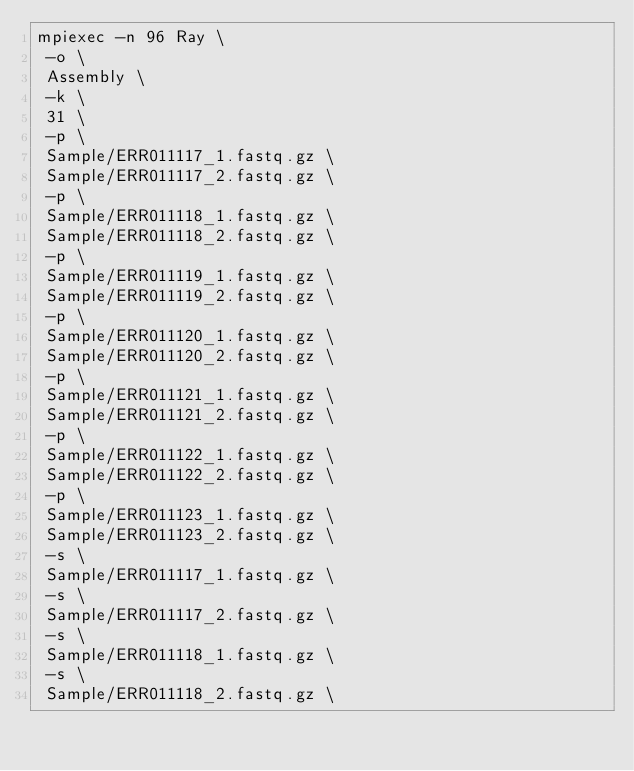Convert code to text. <code><loc_0><loc_0><loc_500><loc_500><_Bash_>mpiexec -n 96 Ray \
 -o \
 Assembly \
 -k \
 31 \
 -p \
 Sample/ERR011117_1.fastq.gz \
 Sample/ERR011117_2.fastq.gz \
 -p \
 Sample/ERR011118_1.fastq.gz \
 Sample/ERR011118_2.fastq.gz \
 -p \
 Sample/ERR011119_1.fastq.gz \
 Sample/ERR011119_2.fastq.gz \
 -p \
 Sample/ERR011120_1.fastq.gz \
 Sample/ERR011120_2.fastq.gz \
 -p \
 Sample/ERR011121_1.fastq.gz \
 Sample/ERR011121_2.fastq.gz \
 -p \
 Sample/ERR011122_1.fastq.gz \
 Sample/ERR011122_2.fastq.gz \
 -p \
 Sample/ERR011123_1.fastq.gz \
 Sample/ERR011123_2.fastq.gz \
 -s \
 Sample/ERR011117_1.fastq.gz \
 -s \
 Sample/ERR011117_2.fastq.gz \
 -s \
 Sample/ERR011118_1.fastq.gz \
 -s \
 Sample/ERR011118_2.fastq.gz \</code> 